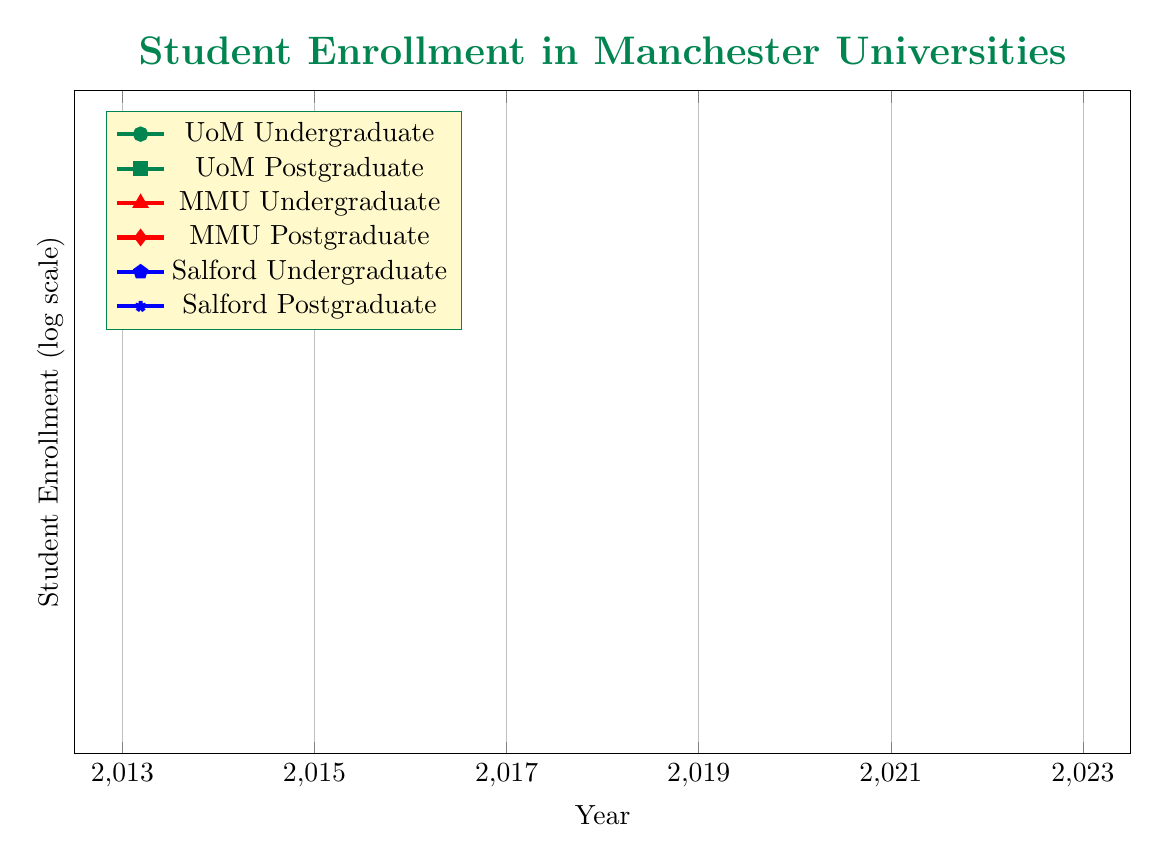What was the undergraduate enrollment at the University of Manchester in 2019? The table shows a row for the University of Manchester specifically for the year 2019, which indicates the undergraduate enrollment to be 27000.
Answer: 27000 How many postgraduate students were enrolled at Manchester Metropolitan University in 2014? From the table, in the year 2014 under Manchester Metropolitan University, the postgraduate enrollment is listed as 9000.
Answer: 9000 What is the total number of undergraduate students enrolled across all universities in 2023? To find the total for 2023, we add each university's undergraduate enrollment: 33000 (MMU) + 0 (UoM not listed) + 0 (Salford not listed) = 33000.
Answer: 33000 What was the percentage increase in undergraduate enrollment for the University of Salford from 2015 to 2021? The undergraduate enrollment for Salford in 2015 was 15000, and in 2021 it was 17000. The increase is 17000 - 15000 = 2000. To find the percentage increase: (2000 / 15000) * 100 = 13.33%.
Answer: 13.33% Did the number of postgraduate students at the University of Manchester increase every year from 2013 to 2022? Looking at the data, the postgraduate numbers for UoM are 12000 (2013), 12500 (2016), 13000 (2019), and 13500 (2022). All these numbers increase over the years, hence the statement is true.
Answer: Yes Which university had the highest total student enrollment (undergraduate plus postgraduate) in 2020? The total for Manchester Metropolitan University in 2020 is 32000 (undergraduate) + 10000 (postgraduate) = 42000. Meanwhile, UoM and Salford have lower totals. Hence MMU has the highest total enrollment in that year.
Answer: Manchester Metropolitan University What is the average number of postgraduate students enrolled at the University of Salford over the years represented? The postgraduate enrollments for Salford are 4000 (2015), 4500 (2018), and 5000 (2021). The average is (4000 + 4500 + 5000) / 3 = 4500.
Answer: 4500 What was the undergraduate enrollment trend for the University of Manchester from 2013 to 2022? Analyzing the years: 26000 (2013), 26500 (2016), 27000 (2019), and 27500 (2022). This shows a consistent increase over the observed years. Thus, the trend is upward.
Answer: Upward trend 